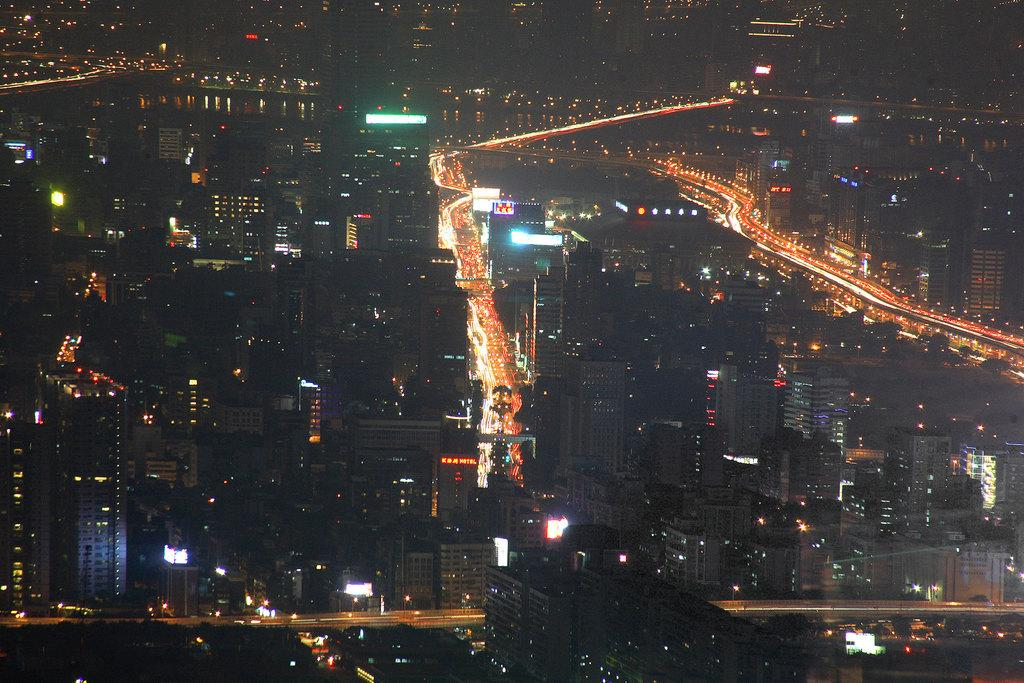What type of view is provided in the image? The image is an aerial view. What structures can be seen from this perspective? There are buildings visible in the image. Are there any indications of activity within the buildings? Yes, there are lights in the buildings, which may suggest that they are occupied or in use. What else can be seen in the image besides the buildings? There are roads visible in the image. Can you tell me how many rats are crossing the bridge in the image? There is no bridge or rats present in the image; it features an aerial view of buildings and roads. 